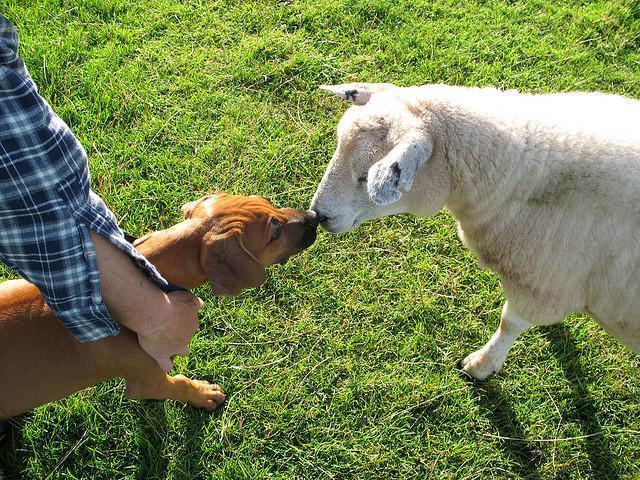How many dogs are there?
Give a very brief answer. 1. 